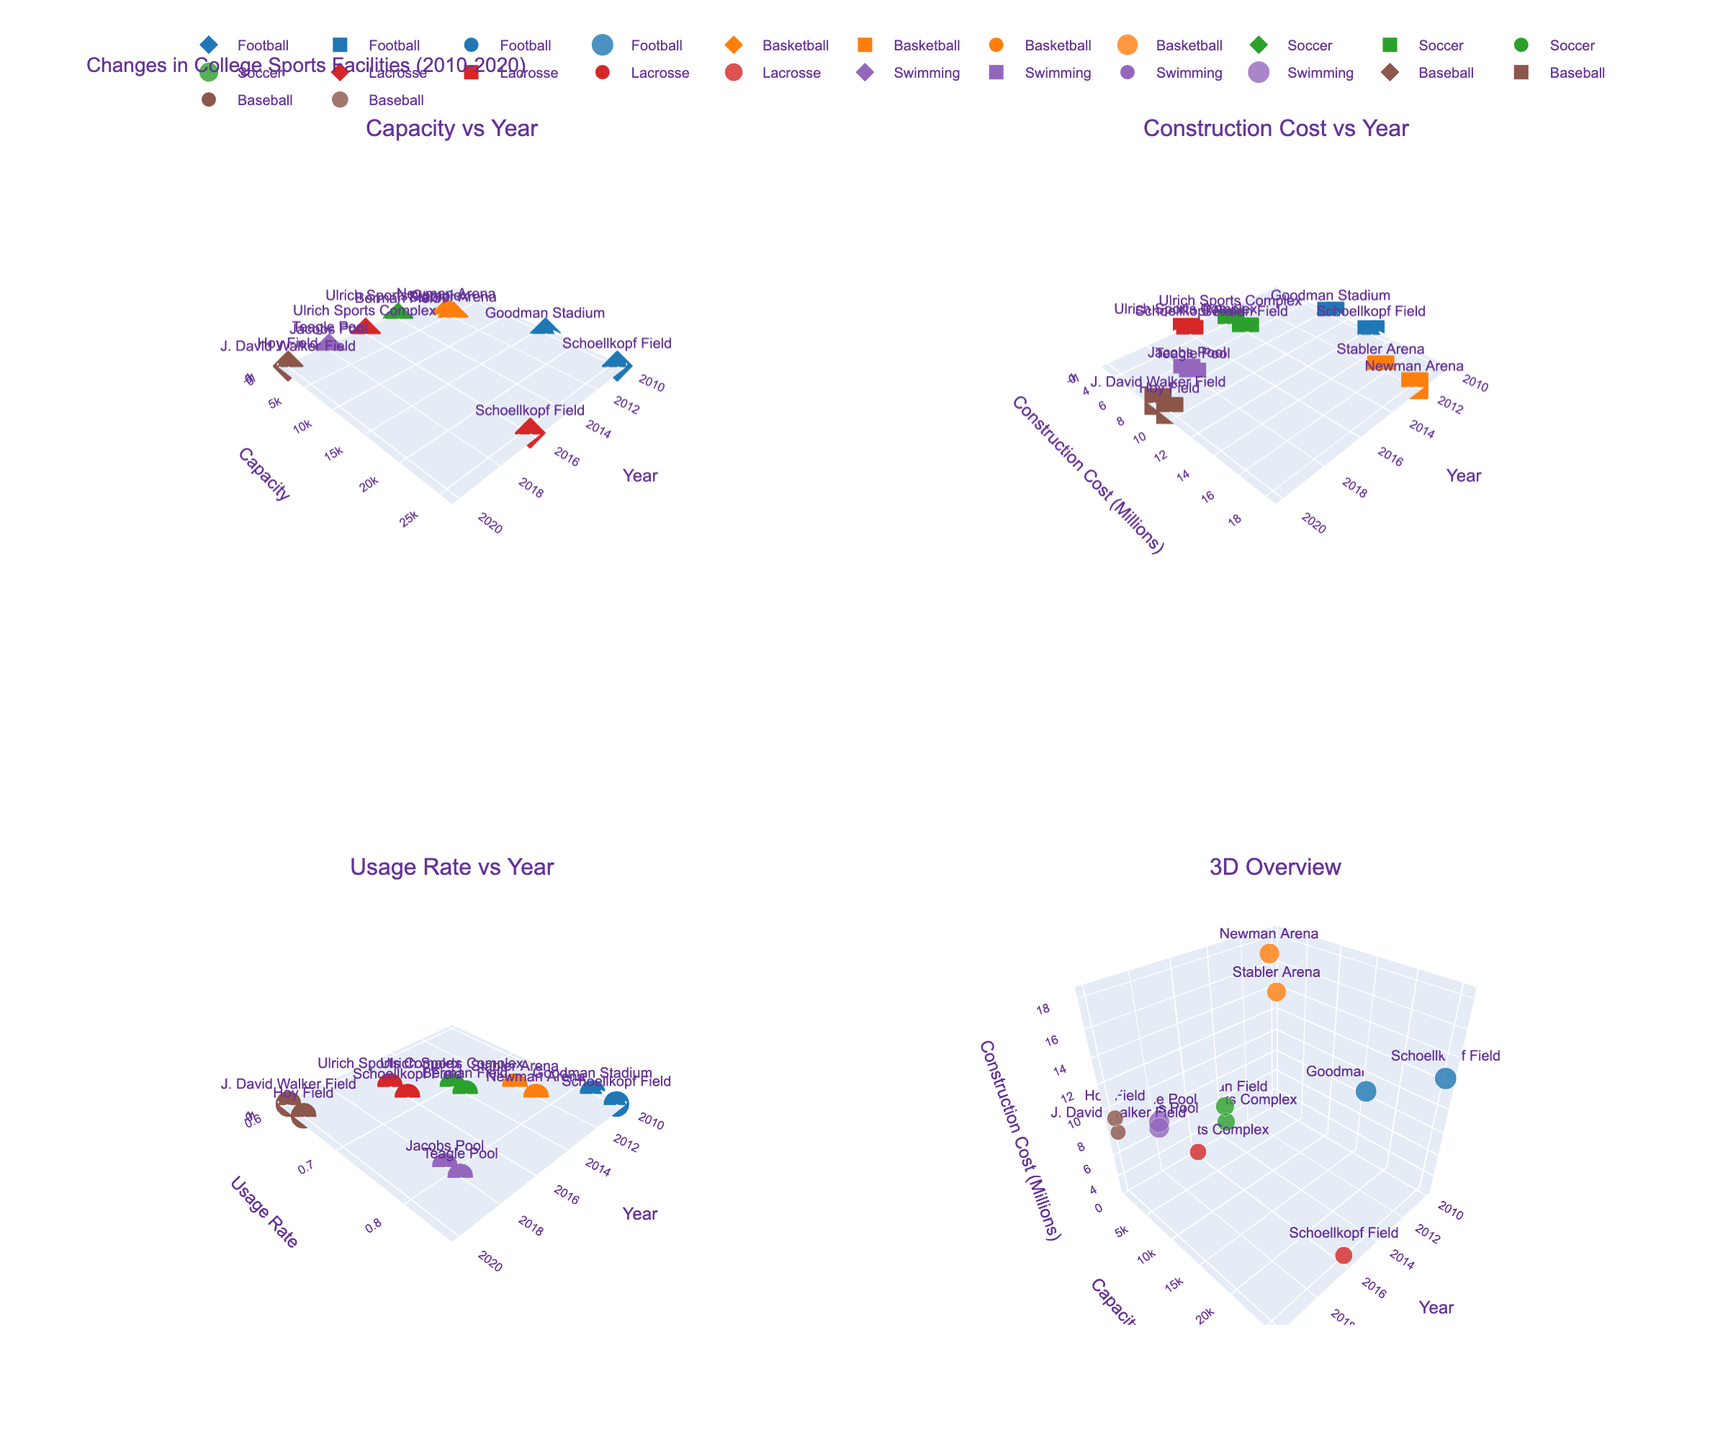What is the title of the figure? The title of the figure is displayed at the top and is "Changes in College Sports Facilities (2010-2020)"
Answer: Changes in College Sports Facilities (2010-2020) In the "Capacity vs Year" subplot, what is the capacity of Schoellkopf Field in 2016? Look at the "Capacity vs Year" subplot, locate the year 2016, find the marker associated with Schoellkopf Field, and read the capacity value.
Answer: 25,597 Which program appears to have the highest construction cost for their facility in 2020? In the "Construction Cost vs Year" subplot, locate the year 2020, compare the heights of the markers, and identify the program associated with the highest marker.
Answer: Baseball For the "Usage Rate vs Year" subplot, which facility had the highest usage rate in 2020? Check the "Usage Rate vs Year" subplot, find the markers at year 2020, and look for the highest value on the y-axis. Identify the associated facility from the annotations.
Answer: Teagle Pool In the "3D Overview" subplot, which program shows a facility with the lowest capacity during the entire period? In the "3D Overview" subplot, observe the y-axis (Capacity), and identify the minimum value in terms of height. Check the associated program.
Answer: Baseball What is the overall trend in usage rates from 2010 to 2020? Examine the "Usage Rate vs Year" subplot, follow the markers from 2010 to 2020, and observe the general direction (increasing or decreasing).
Answer: Decreasing Between 2012 and 2018, which facility showed a significant increase in construction costs? In the "Construction Cost vs Year" subplot, compare the markers from 2012 to 2018 and observe any facilities with a marked increase in height.
Answer: Newman Arena Compare the capacities of soccer and lacrosse facilities in 2014. Which one had a higher capacity? Look at the "Capacity vs Year" subplot, locate 2014, and compare the heights of the markers for soccer (Berman Field) and lacrosse (Ulrich Sports Complex).
Answer: Lacrosse How does the construction cost of Newman Arena in 2012 compare to that of Stabler Arena in the same year? Check both markers in the "Construction Cost vs Year" subplot for the year 2012, and compare their heights.
Answer: Newman Arena is higher Do any facilities show a constant capacity from 2010 to 2020? If so, which one? Observe the "Capacity vs Year" subplot, and look for any markers that stay at the same height throughout the years. Identify the associated facility.
Answer: Schoellkopf Field 